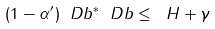Convert formula to latex. <formula><loc_0><loc_0><loc_500><loc_500>( 1 - \alpha ^ { \prime } ) \ D b ^ { * } \ D b \leq \ H + \gamma</formula> 